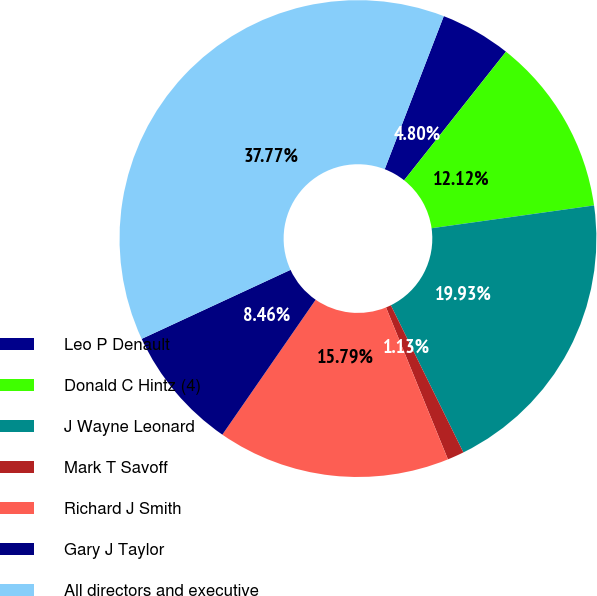<chart> <loc_0><loc_0><loc_500><loc_500><pie_chart><fcel>Leo P Denault<fcel>Donald C Hintz (4)<fcel>J Wayne Leonard<fcel>Mark T Savoff<fcel>Richard J Smith<fcel>Gary J Taylor<fcel>All directors and executive<nl><fcel>4.8%<fcel>12.12%<fcel>19.93%<fcel>1.13%<fcel>15.79%<fcel>8.46%<fcel>37.77%<nl></chart> 